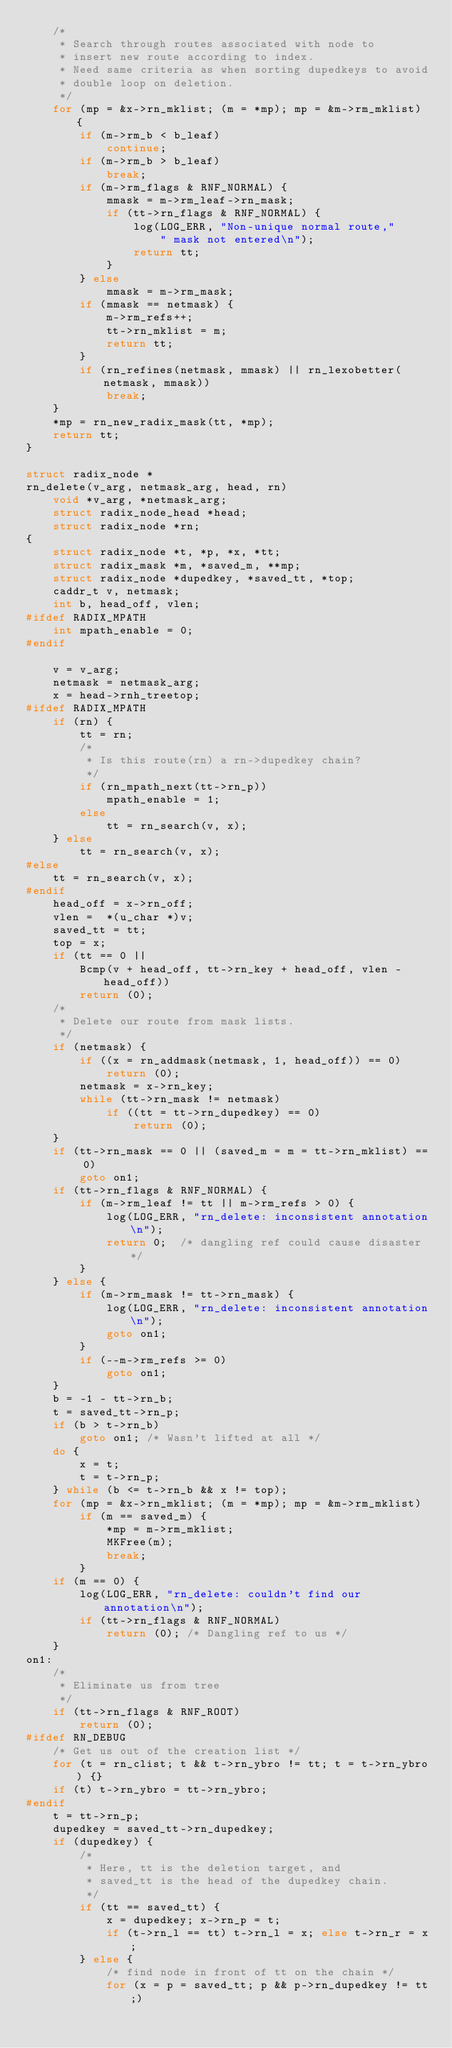Convert code to text. <code><loc_0><loc_0><loc_500><loc_500><_C_>	/*
	 * Search through routes associated with node to
	 * insert new route according to index.
	 * Need same criteria as when sorting dupedkeys to avoid
	 * double loop on deletion.
	 */
	for (mp = &x->rn_mklist; (m = *mp); mp = &m->rm_mklist) {
		if (m->rm_b < b_leaf)
			continue;
		if (m->rm_b > b_leaf)
			break;
		if (m->rm_flags & RNF_NORMAL) {
			mmask = m->rm_leaf->rn_mask;
			if (tt->rn_flags & RNF_NORMAL) {
				log(LOG_ERR, "Non-unique normal route,"
				    " mask not entered\n");
				return tt;
			}
		} else
			mmask = m->rm_mask;
		if (mmask == netmask) {
			m->rm_refs++;
			tt->rn_mklist = m;
			return tt;
		}
		if (rn_refines(netmask, mmask) || rn_lexobetter(netmask, mmask))
			break;
	}
	*mp = rn_new_radix_mask(tt, *mp);
	return tt;
}

struct radix_node *
rn_delete(v_arg, netmask_arg, head, rn)
	void *v_arg, *netmask_arg;
	struct radix_node_head *head;
	struct radix_node *rn;
{
	struct radix_node *t, *p, *x, *tt;
	struct radix_mask *m, *saved_m, **mp;
	struct radix_node *dupedkey, *saved_tt, *top;
	caddr_t v, netmask;
	int b, head_off, vlen;
#ifdef RADIX_MPATH
	int mpath_enable = 0;
#endif

	v = v_arg;
	netmask = netmask_arg;
	x = head->rnh_treetop;
#ifdef RADIX_MPATH
	if (rn) {
		tt = rn;
		/* 
		 * Is this route(rn) a rn->dupedkey chain? 
		 */
		if (rn_mpath_next(tt->rn_p))
			mpath_enable = 1;
		else
			tt = rn_search(v, x);
	} else
		tt = rn_search(v, x);
#else
	tt = rn_search(v, x);
#endif
	head_off = x->rn_off;
	vlen =  *(u_char *)v;
	saved_tt = tt;
	top = x;
	if (tt == 0 ||
	    Bcmp(v + head_off, tt->rn_key + head_off, vlen - head_off))
		return (0);
	/*
	 * Delete our route from mask lists.
	 */
	if (netmask) {
		if ((x = rn_addmask(netmask, 1, head_off)) == 0)
			return (0);
		netmask = x->rn_key;
		while (tt->rn_mask != netmask)
			if ((tt = tt->rn_dupedkey) == 0)
				return (0);
	}
	if (tt->rn_mask == 0 || (saved_m = m = tt->rn_mklist) == 0)
		goto on1;
	if (tt->rn_flags & RNF_NORMAL) {
		if (m->rm_leaf != tt || m->rm_refs > 0) {
			log(LOG_ERR, "rn_delete: inconsistent annotation\n");
			return 0;  /* dangling ref could cause disaster */
		}
	} else { 
		if (m->rm_mask != tt->rn_mask) {
			log(LOG_ERR, "rn_delete: inconsistent annotation\n");
			goto on1;
		}
		if (--m->rm_refs >= 0)
			goto on1;
	}
	b = -1 - tt->rn_b;
	t = saved_tt->rn_p;
	if (b > t->rn_b)
		goto on1; /* Wasn't lifted at all */
	do {
		x = t;
		t = t->rn_p;
	} while (b <= t->rn_b && x != top);
	for (mp = &x->rn_mklist; (m = *mp); mp = &m->rm_mklist)
		if (m == saved_m) {
			*mp = m->rm_mklist;
			MKFree(m);
			break;
		}
	if (m == 0) {
		log(LOG_ERR, "rn_delete: couldn't find our annotation\n");
		if (tt->rn_flags & RNF_NORMAL)
			return (0); /* Dangling ref to us */
	}
on1:
	/*
	 * Eliminate us from tree
	 */
	if (tt->rn_flags & RNF_ROOT)
		return (0);
#ifdef RN_DEBUG
	/* Get us out of the creation list */
	for (t = rn_clist; t && t->rn_ybro != tt; t = t->rn_ybro) {}
	if (t) t->rn_ybro = tt->rn_ybro;
#endif
	t = tt->rn_p;
	dupedkey = saved_tt->rn_dupedkey;
	if (dupedkey) {
		/*
		 * Here, tt is the deletion target, and
		 * saved_tt is the head of the dupedkey chain.
		 */
		if (tt == saved_tt) {
			x = dupedkey; x->rn_p = t;
			if (t->rn_l == tt) t->rn_l = x; else t->rn_r = x;
		} else {
			/* find node in front of tt on the chain */
			for (x = p = saved_tt; p && p->rn_dupedkey != tt;)</code> 